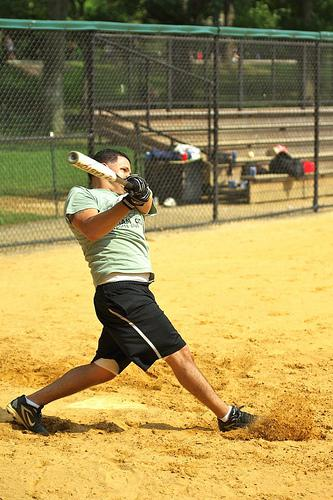Question: what color is the dirt?
Choices:
A. Tan.
B. Brown.
C. Mauve.
D. Beige.
Answer with the letter. Answer: A Question: where is the photo taken?
Choices:
A. A dugout.
B. A baseball field.
C. The park.
D. Middle of the street.
Answer with the letter. Answer: B Question: why is the man sliding?
Choices:
A. From the force of the swing.
B. Going down a slide.
C. He wants to.
D. He's on ice.
Answer with the letter. Answer: A Question: who is wearing shorts?
Choices:
A. The catcher.
B. The pitcher.
C. The batter.
D. The coach.
Answer with the letter. Answer: C Question: how does he swing?
Choices:
A. While sitting.
B. With the bat.
C. While standing on one foot.
D. While looking the other way.
Answer with the letter. Answer: B Question: what is the man doing?
Choices:
A. Swinging for the ball.
B. Catching the ball.
C. Throwing the ball.
D. Dropping the ball.
Answer with the letter. Answer: A 